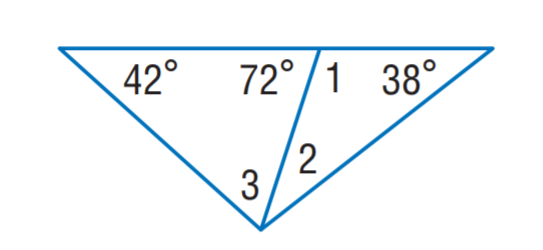Answer the mathemtical geometry problem and directly provide the correct option letter.
Question: Find m \angle 1.
Choices: A: 42 B: 72 C: 108 D: 120 C 